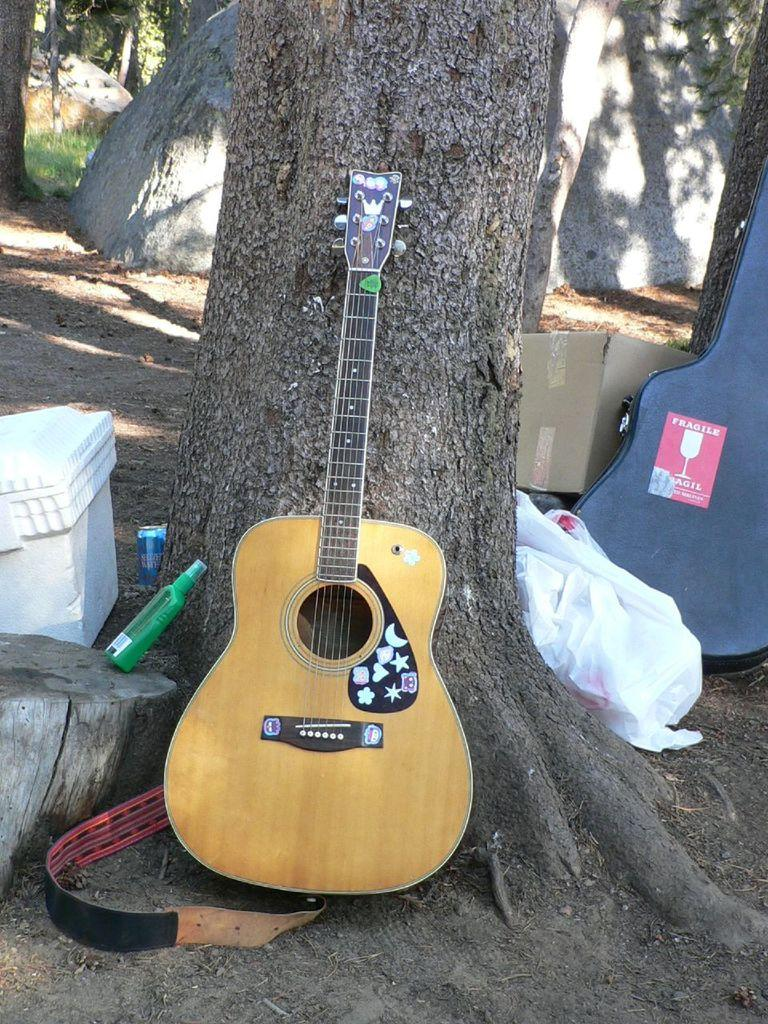What is the main object in the middle of the image? There is a guitar, a bottle, a box, and a tree in the middle of the image. What other objects can be seen in the middle of the image? Besides the guitar, bottle, box, and tree, there is also a box in the middle of the image. What is located on the right side of the image? There is a bag, a box, trees, and a stone on the right side of the image. How many geese are flying over the trees in the image? There are no geese present in the image. What type of ear is visible on the guitar in the image? The image does not show the guitar's ear, as guitars do not have ears. 